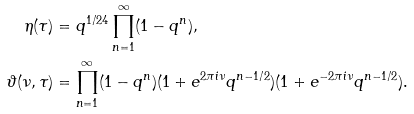Convert formula to latex. <formula><loc_0><loc_0><loc_500><loc_500>\eta ( \tau ) & = q ^ { 1 / 2 4 } \prod _ { n = 1 } ^ { \infty } ( 1 - q ^ { n } ) , \\ \vartheta ( \nu , \tau ) & = \prod _ { n = 1 } ^ { \infty } ( 1 - q ^ { n } ) ( 1 + e ^ { 2 \pi i \nu } q ^ { n - 1 / 2 } ) ( 1 + e ^ { - 2 \pi i \nu } q ^ { n - 1 / 2 } ) .</formula> 